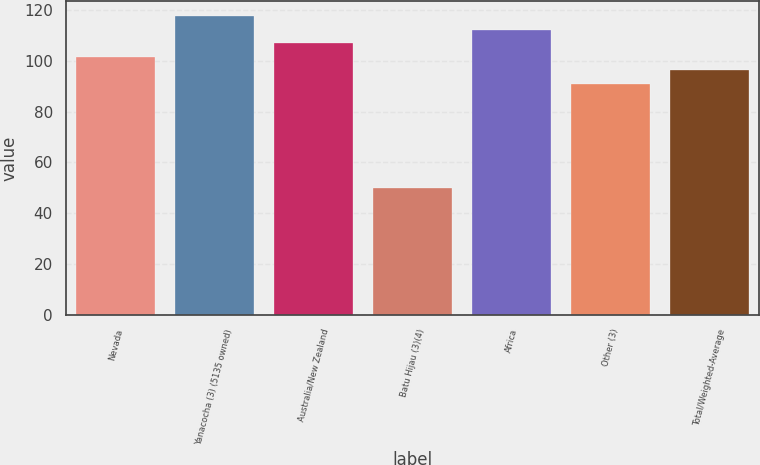Convert chart to OTSL. <chart><loc_0><loc_0><loc_500><loc_500><bar_chart><fcel>Nevada<fcel>Yanacocha (3) (5135 owned)<fcel>Australia/New Zealand<fcel>Batu Hijau (3)(4)<fcel>Africa<fcel>Other (3)<fcel>Total/Weighted-Average<nl><fcel>101.6<fcel>117.5<fcel>106.9<fcel>50<fcel>112.2<fcel>91<fcel>96.3<nl></chart> 